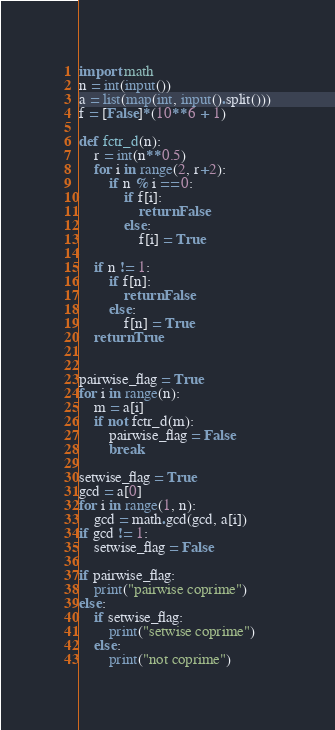<code> <loc_0><loc_0><loc_500><loc_500><_Python_>import math
n = int(input())
a = list(map(int, input().split()))
f = [False]*(10**6 + 1)

def fctr_d(n):
    r = int(n**0.5)
    for i in range(2, r+2):
        if n % i == 0:
            if f[i]:
                return False
            else:
                f[i] = True

    if n != 1:
        if f[n]:
            return False
        else:
            f[n] = True
    return True


pairwise_flag = True
for i in range(n):
    m = a[i]
    if not fctr_d(m):
        pairwise_flag = False
        break

setwise_flag = True
gcd = a[0]
for i in range(1, n):
    gcd = math.gcd(gcd, a[i])
if gcd != 1:
    setwise_flag = False

if pairwise_flag:
    print("pairwise coprime")
else:
    if setwise_flag:
        print("setwise coprime")
    else:
        print("not coprime")



</code> 